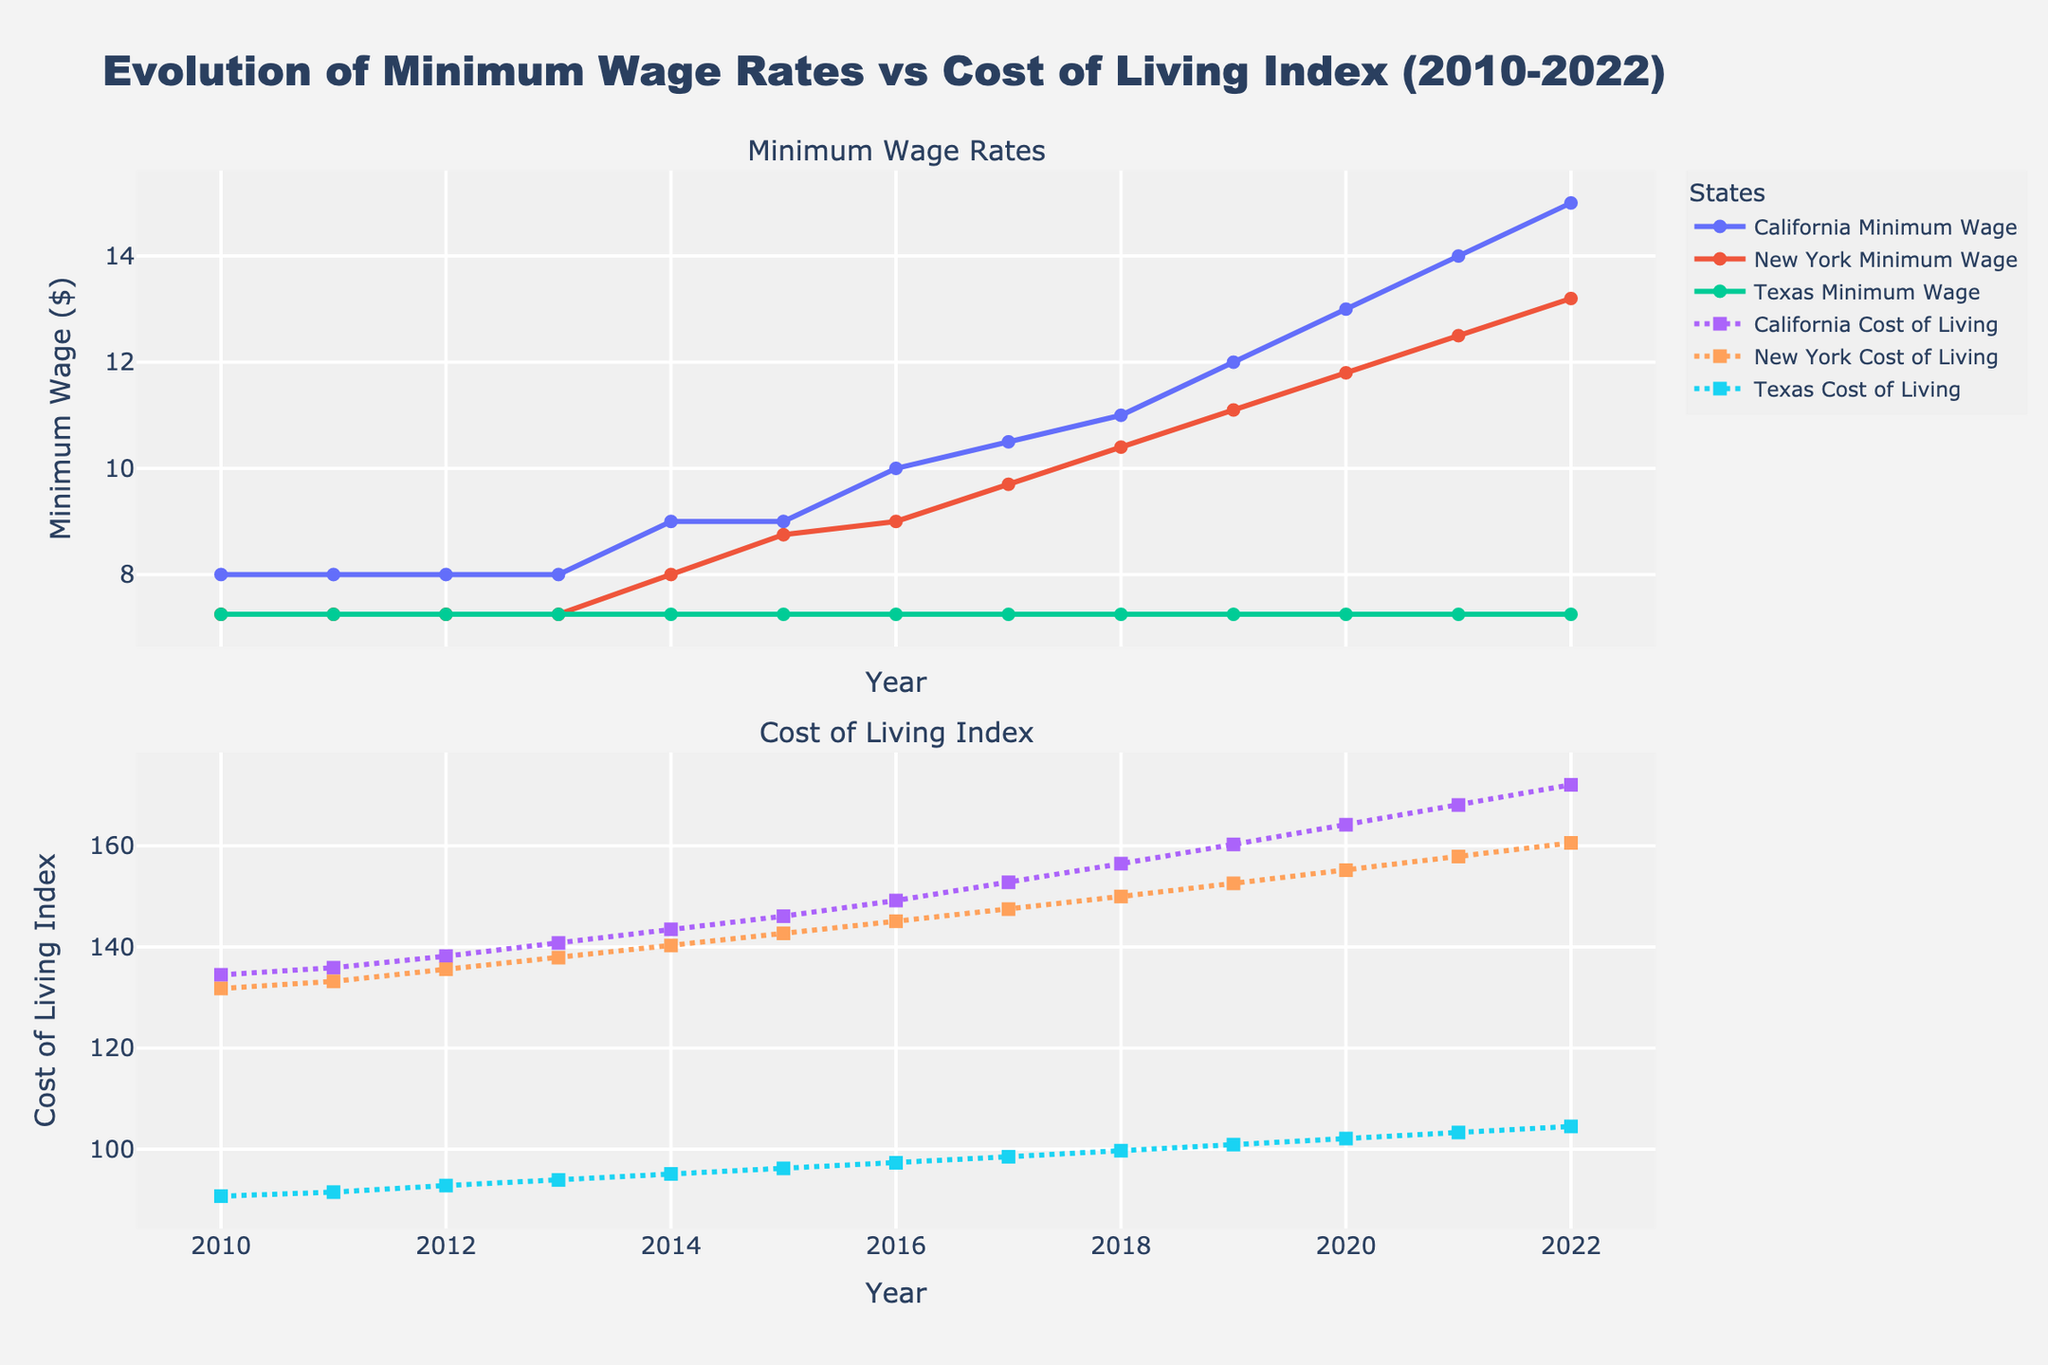What's the difference in the Minimum Wage between California and Texas in 2022? In 2022, the minimum wage in California is $15.00, and in Texas, it is $7.25. The difference is 15.00 - 7.25
Answer: $7.75 How did the Minimum Wage in New York change from 2010 to 2022? The minimum wage in New York in 2010 was $7.25, and it increased to $13.20 in 2022.
Answer: Increased by $5.95 Which state had the highest Cost of Living Index in 2022? By looking at the Cost of Living Index in 2022, California had the highest value.
Answer: California Compare the Cost of Living Index growth from 2010 to 2022 between California and Texas. California's Cost of Living Index grew from 134.5 to 172.1 (an increase of 37.6), while Texas' index grew from 90.7 to 104.5 (an increase of 13.8). Therefore, California had a greater absolute increase.
Answer: California What's the average Minimum Wage in California from 2010 to 2022? Sum all the minimum wages in California from 2010 to 2022 (8.00 + 8.00 + 8.00 + 8.00 + 9.00 + 9.00 + 10.00 + 10.50 + 11.00 + 12.00 + 13.00 + 14.00 + 15.00) and then divide by the number of years (13). This gives (136.5/13).
Answer: $10.50 In which year did New York's Minimum Wage first surpass $10.00? The first year where New York's Minimum Wage is above $10.00 is 2018, where it is $10.40.
Answer: 2018 How does the trend in Texas Minimum Wage compare to the trend in Texas Cost of Living Index from 2010 to 2022? The Texas Minimum Wage remains constant at $7.25 from 2010 to 2022, while the Texas Cost of Living Index increases steadily from 90.7 to 104.5.
Answer: Minimum Wage is constant, Cost of Living increases What is the total increase in Minimum Wage for California between 2010 and 2022? The minimum wage in California in 2010 was $8.00, and in 2022 it was $15.00. The total increase is 15.00 - 8.00.
Answer: $7.00 